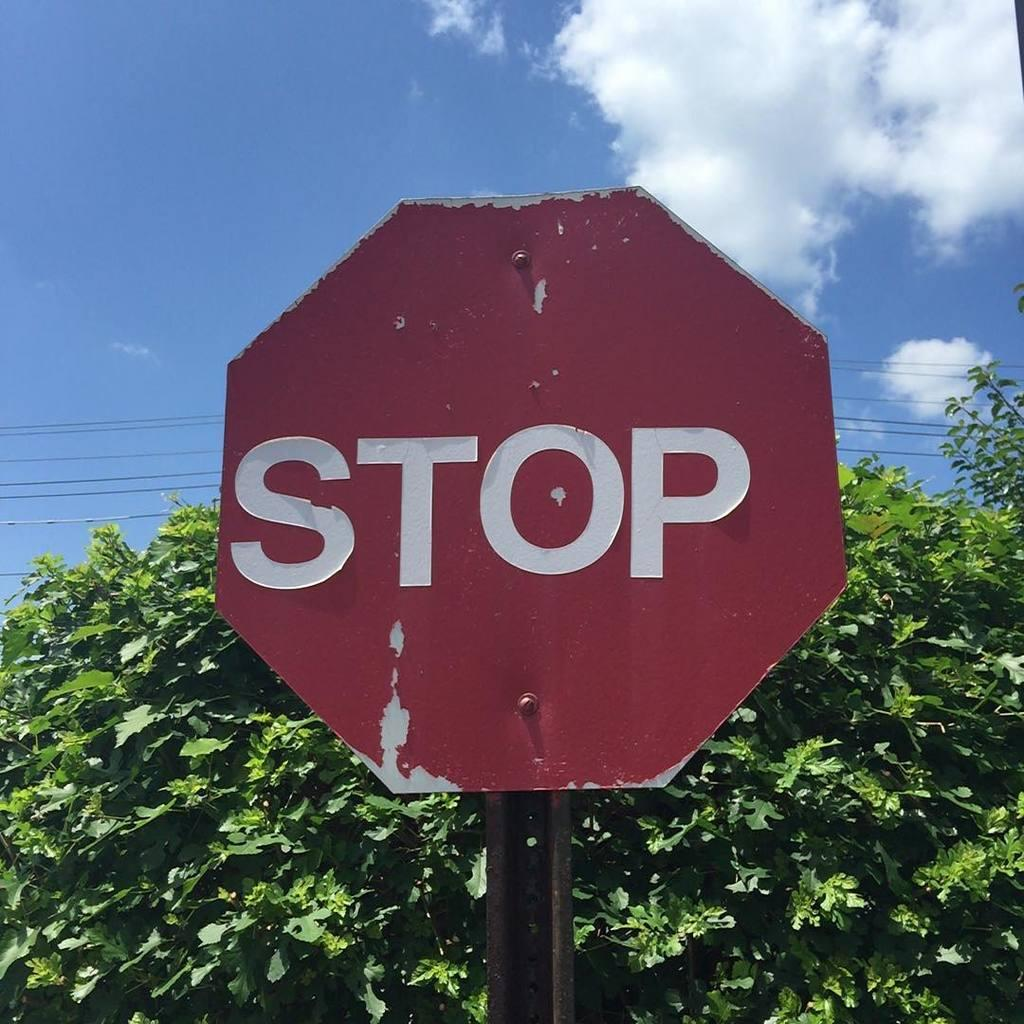<image>
Relay a brief, clear account of the picture shown. A worn red sign indicates motorists to stop. 